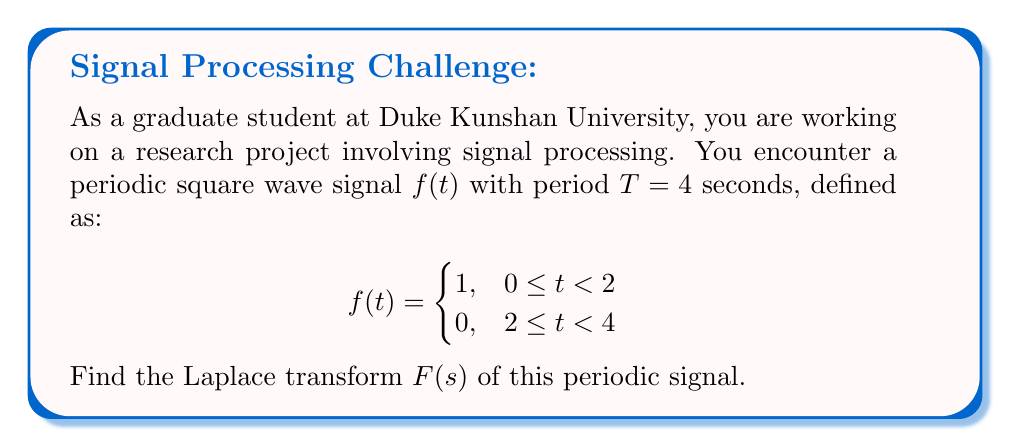What is the answer to this math problem? To solve this problem using Laplace transforms, we'll follow these steps:

1) First, recall the formula for the Laplace transform of a periodic function:

   $$F(s) = \frac{\int_0^T f(t)e^{-st}dt}{1-e^{-sT}}$$

   where $T$ is the period of the function.

2) In our case, $T=4$ and we need to evaluate the integral in the numerator:

   $$\int_0^4 f(t)e^{-st}dt$$

3) We can split this integral into two parts based on the definition of $f(t)$:

   $$\int_0^2 1 \cdot e^{-st}dt + \int_2^4 0 \cdot e^{-st}dt$$

4) The second integral is zero, so we only need to evaluate:

   $$\int_0^2 e^{-st}dt$$

5) Evaluating this integral:

   $$\left[-\frac{1}{s}e^{-st}\right]_0^2 = -\frac{1}{s}e^{-2s} + \frac{1}{s} = \frac{1-e^{-2s}}{s}$$

6) Now, we can substitute this result into the formula from step 1:

   $$F(s) = \frac{\frac{1-e^{-2s}}{s}}{1-e^{-4s}}$$

7) Simplify by multiplying numerator and denominator by $s$:

   $$F(s) = \frac{1-e^{-2s}}{s(1-e^{-4s})}$$

This is the Laplace transform of the given periodic square wave signal.
Answer: $$F(s) = \frac{1-e^{-2s}}{s(1-e^{-4s})}$$ 